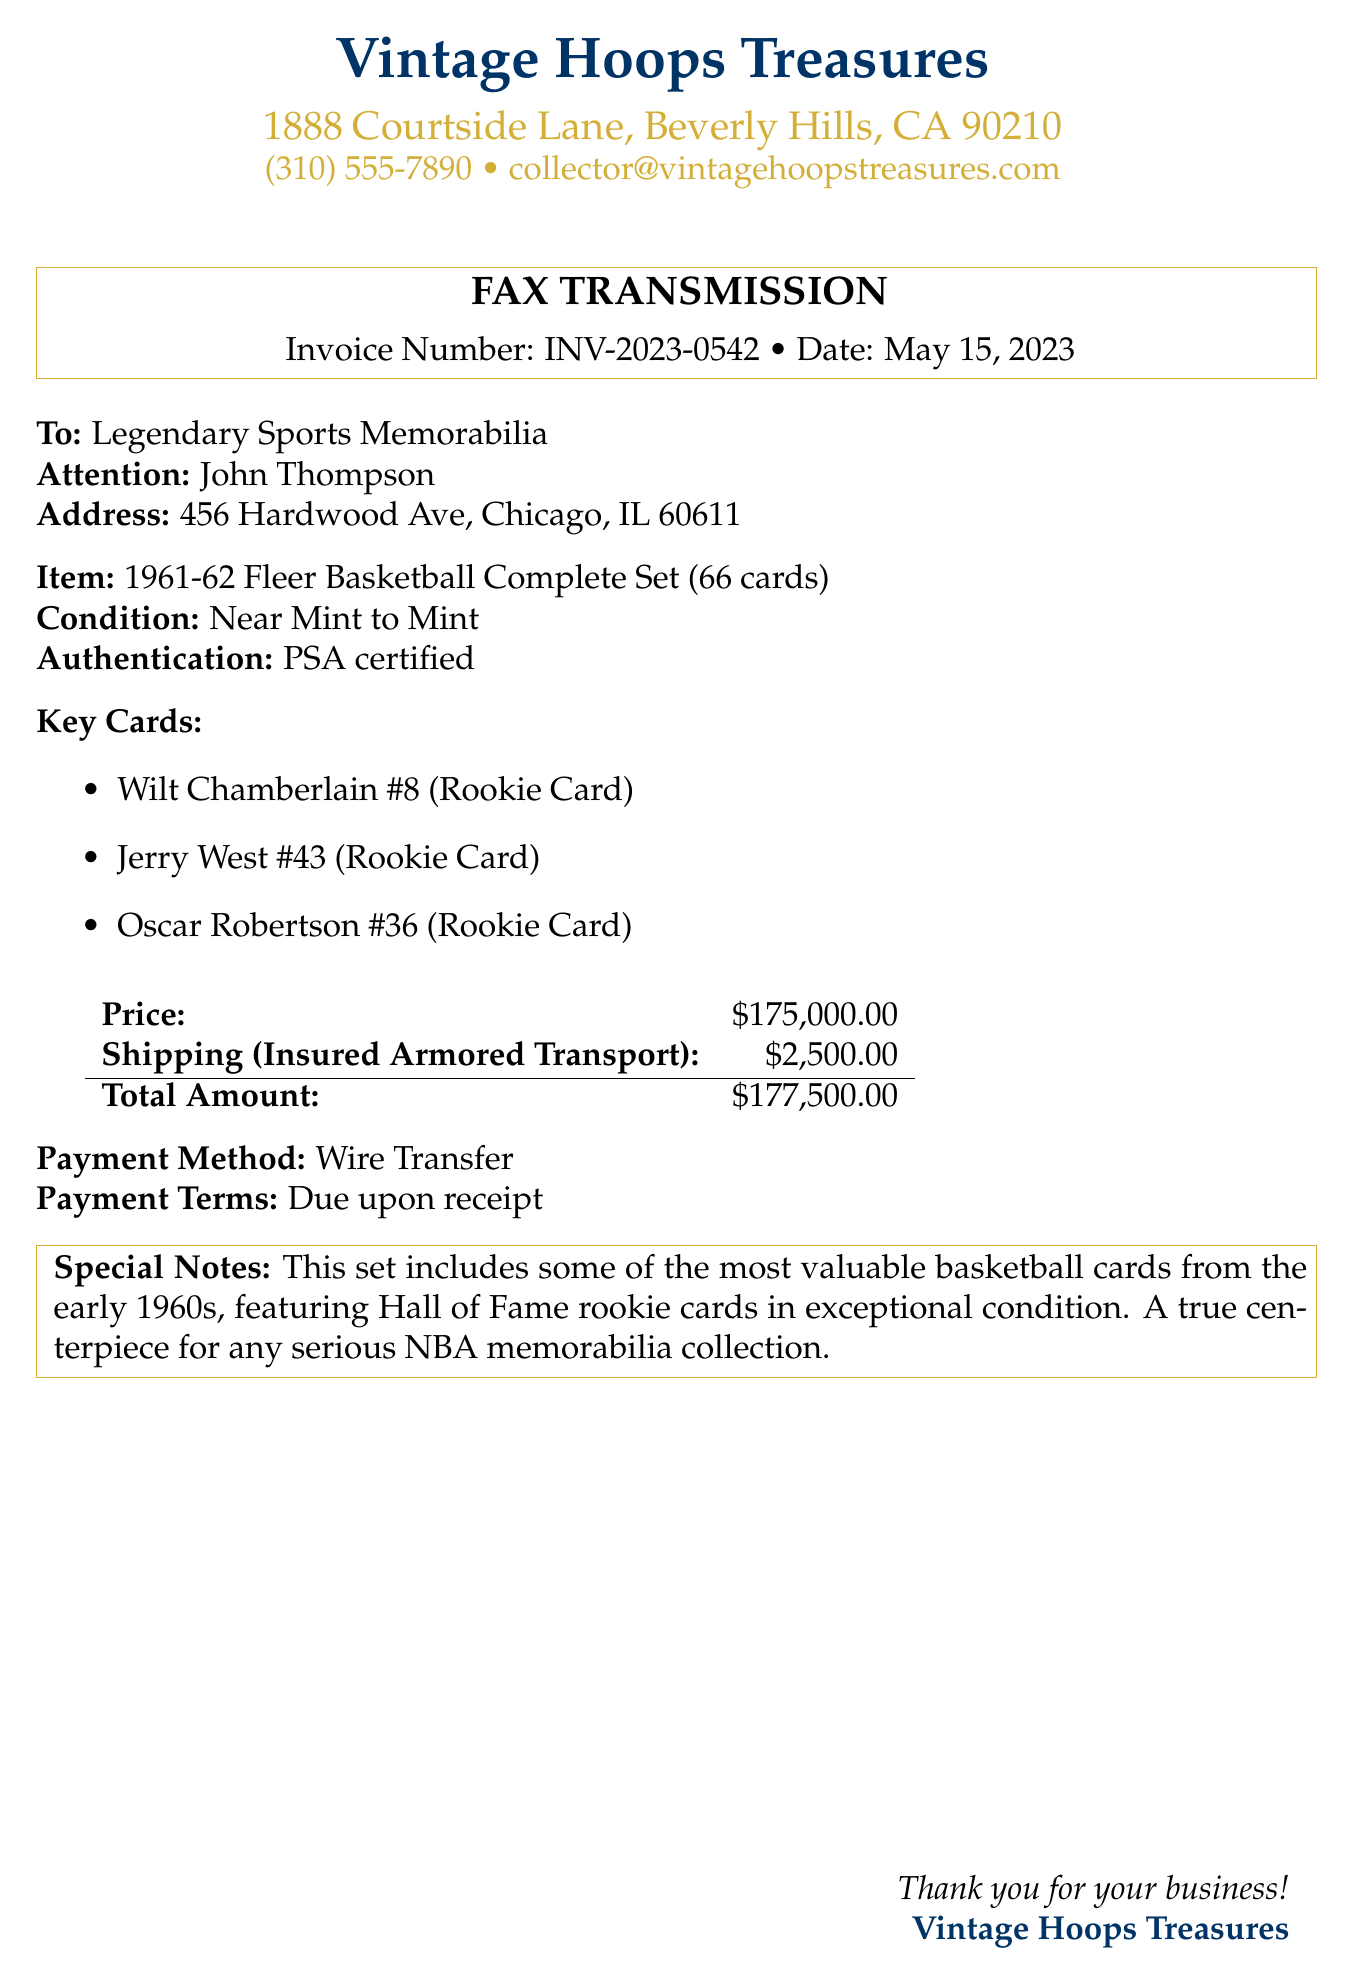what is the invoice number? The invoice number is listed prominently near the top of the document for identification purposes.
Answer: INV-2023-0542 who is the recipient of the fax? The recipient's name and organization are mentioned under the "To:" section in the document.
Answer: Legendary Sports Memorabilia what is the total amount to be paid? The total amount is calculated as the sum of the price and shipping cost in the invoice.
Answer: $177,500.00 what is the condition of the basketball set? The condition of the set is described in a specific section of the invoice detailing the quality of the cards.
Answer: Near Mint to Mint what is the key feature of this basketball card set? The key feature includes the specific cards that are mentioned in the "Key Cards" section.
Answer: Hall of Fame rookie cards what is the shipping method for the cards? The shipping method, specifically mentioned in the pricing section, provides details about the mode of transport for the shipment.
Answer: Insured Armored Transport when was the invoice date? The invoice date is recorded in the header of the document to provide a timeframe for the transaction.
Answer: May 15, 2023 who is the attention person listed in the document? The attention person is specified for clarity on who in the organization should handle the document.
Answer: John Thompson what payment method is specified in the invoice? The payment method is detailed towards the end of the document to clarify how the payment should be made.
Answer: Wire Transfer 